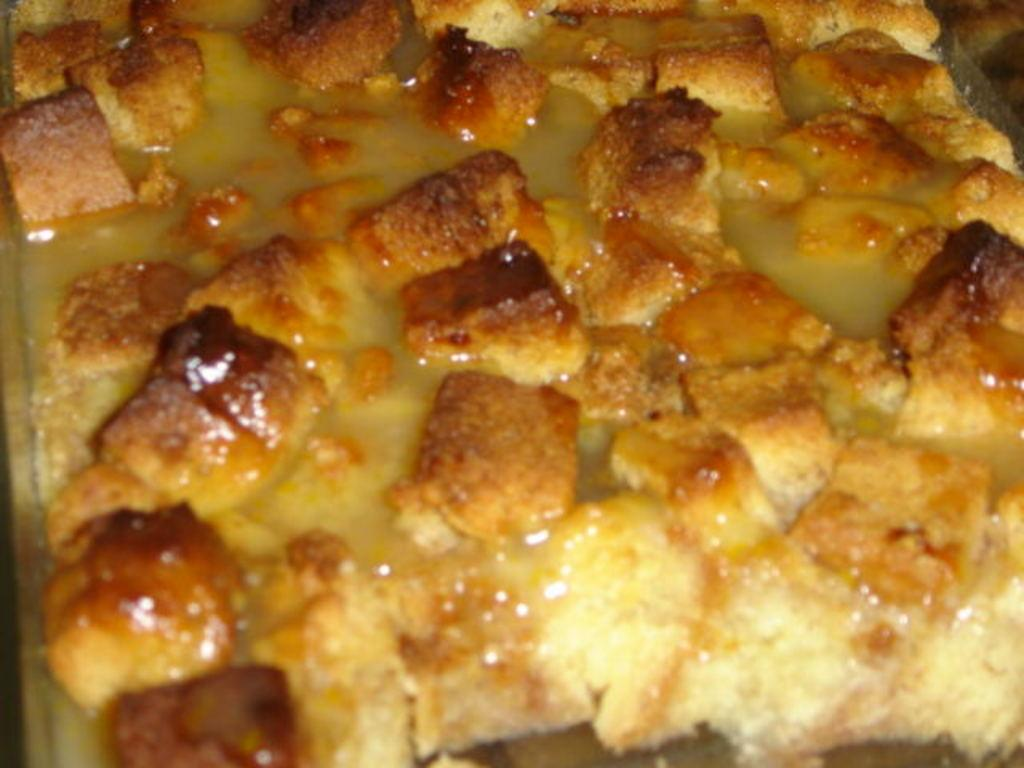What is the main subject of the image? There is a food item in the image. What type of plant can be seen growing next to the food item in the image? There is no plant visible in the image; it only features a food item. Is there a maid present in the image? There is no mention of a maid in the image, as it only features a food item. 